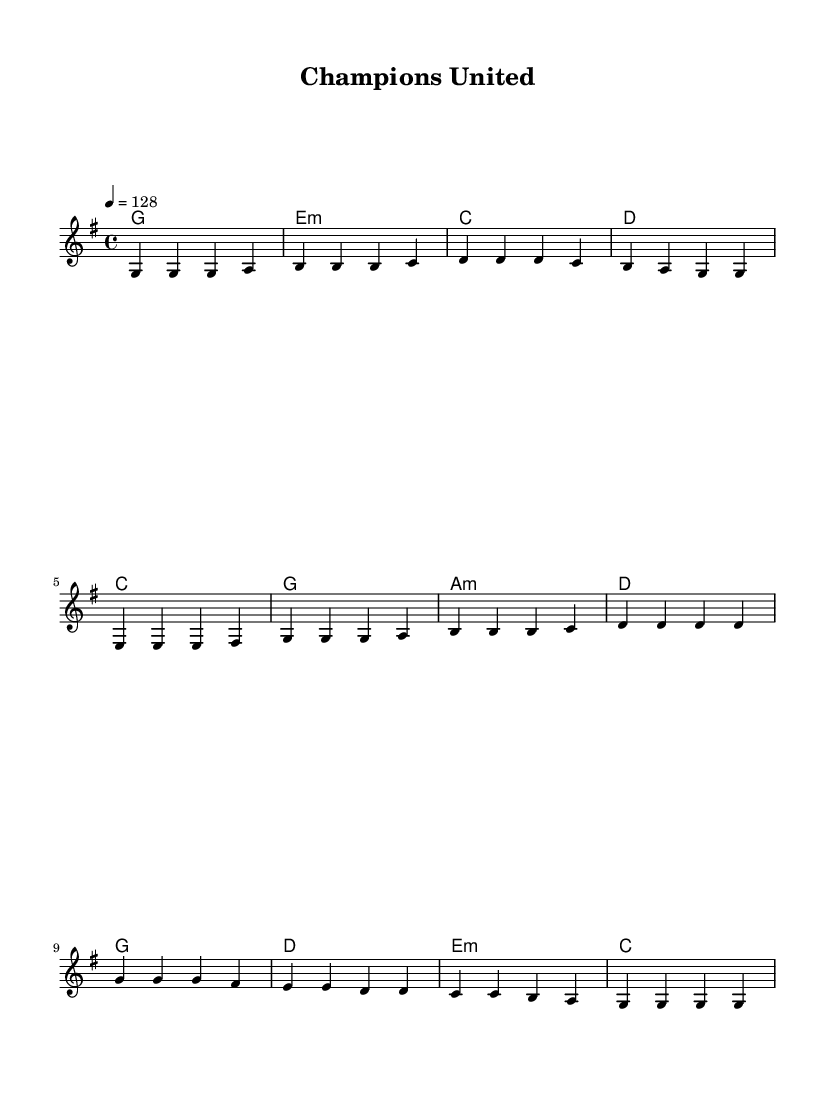What is the key signature of this music? The key signature is G major, which has one sharp (F#).
Answer: G major What is the time signature of this piece? The time signature is 4/4, indicating there are four beats per measure and a quarter note receives one beat.
Answer: 4/4 What is the tempo marking for this piece? The tempo marking is 128 beats per minute, indicating the speed at which the piece should be played.
Answer: 128 How many measures are in the chorus section? The chorus section consists of four measures, as indicated by the grouping of the notes in that section.
Answer: 4 Which chord follows the first melody note of the verse? The first melody note of the verse is G, and it is accompanied by a G major chord.
Answer: G What is the last note of the melody in the chorus? The last note of the melody in the chorus is G, as it concludes the melodic line within that section.
Answer: G Which section of the song is most likely to serve as its main highlight? The chorus is typically considered the main highlight of pop songs, as it is often the catchiest and most memorable part, comprised of a repeated thematic material.
Answer: Chorus 